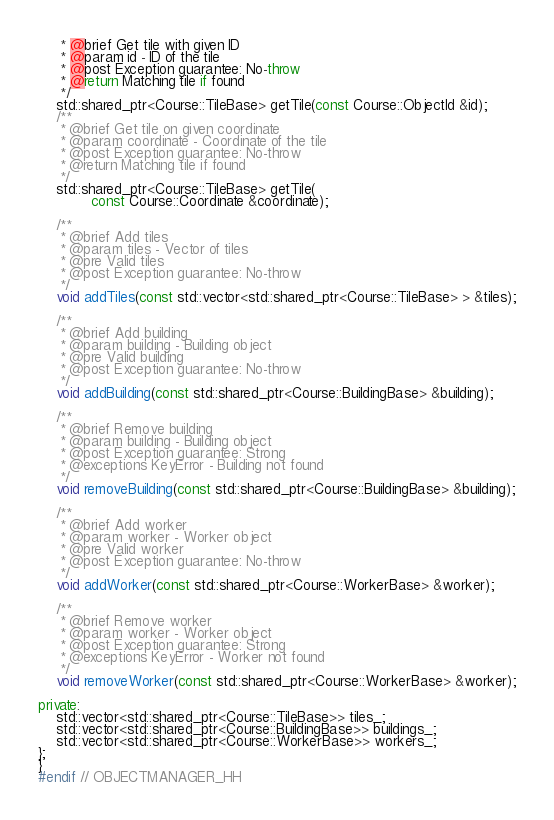<code> <loc_0><loc_0><loc_500><loc_500><_C++_>     * @brief Get tile with given ID
     * @param id - ID of the tile
     * @post Exception guarantee: No-throw
     * @return Matching tile if found
     */
    std::shared_ptr<Course::TileBase> getTile(const Course::ObjectId &id);
    /**
     * @brief Get tile on given coordinate
     * @param coordinate - Coordinate of the tile
     * @post Exception guarantee: No-throw
     * @return Matching tile if found
     */
    std::shared_ptr<Course::TileBase> getTile(
            const Course::Coordinate &coordinate);

    /**
     * @brief Add tiles
     * @param tiles - Vector of tiles
     * @pre Valid tiles
     * @post Exception guarantee: No-throw
     */
    void addTiles(const std::vector<std::shared_ptr<Course::TileBase> > &tiles);

    /**
     * @brief Add building
     * @param building - Building object
     * @pre Valid building
     * @post Exception guarantee: No-throw
     */
    void addBuilding(const std::shared_ptr<Course::BuildingBase> &building);

    /**
     * @brief Remove building
     * @param building - Building object
     * @post Exception guarantee: Strong
     * @exceptions KeyError - Building not found
     */
    void removeBuilding(const std::shared_ptr<Course::BuildingBase> &building);

    /**
     * @brief Add worker
     * @param worker - Worker object
     * @pre Valid worker
     * @post Exception guarantee: No-throw
     */
    void addWorker(const std::shared_ptr<Course::WorkerBase> &worker);

    /**
     * @brief Remove worker
     * @param worker - Worker object
     * @post Exception guarantee: Strong
     * @exceptions KeyError - Worker not found
     */
    void removeWorker(const std::shared_ptr<Course::WorkerBase> &worker);

private:
    std::vector<std::shared_ptr<Course::TileBase>> tiles_;
    std::vector<std::shared_ptr<Course::BuildingBase>> buildings_;
    std::vector<std::shared_ptr<Course::WorkerBase>> workers_;
};
}
#endif // OBJECTMANAGER_HH
</code> 